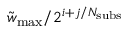<formula> <loc_0><loc_0><loc_500><loc_500>\tilde { w } _ { \max } / 2 ^ { i + j / N _ { s u b s } }</formula> 